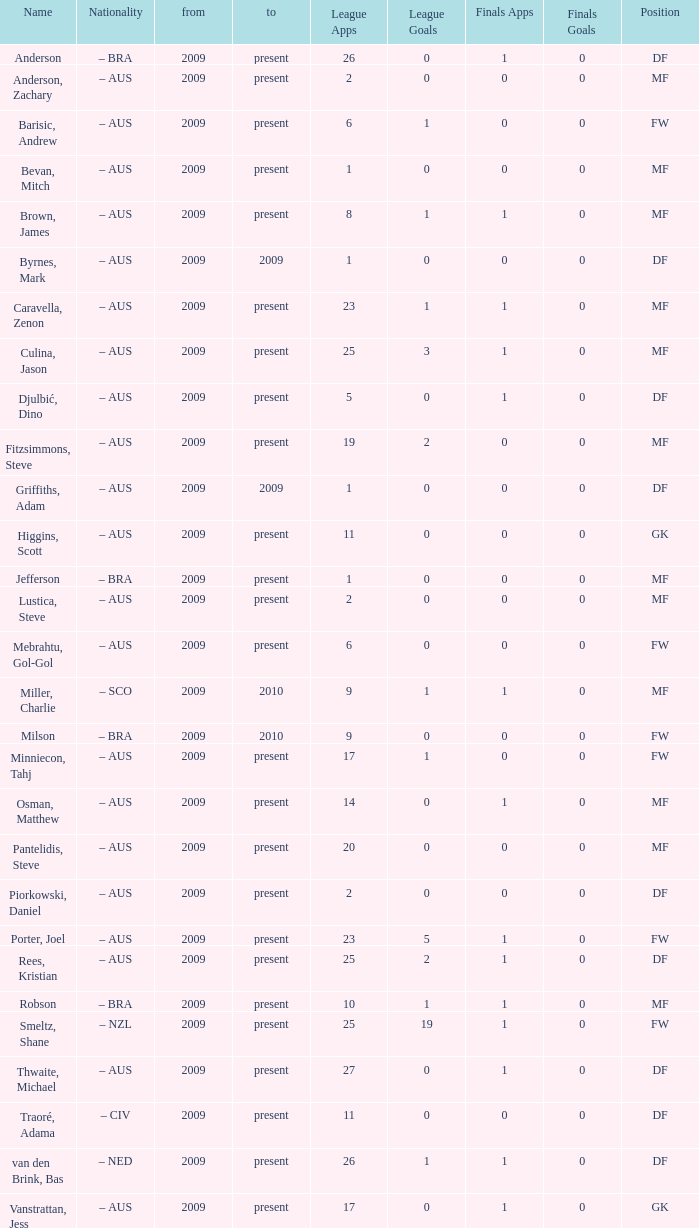What are the top 19 league applications? Present. 